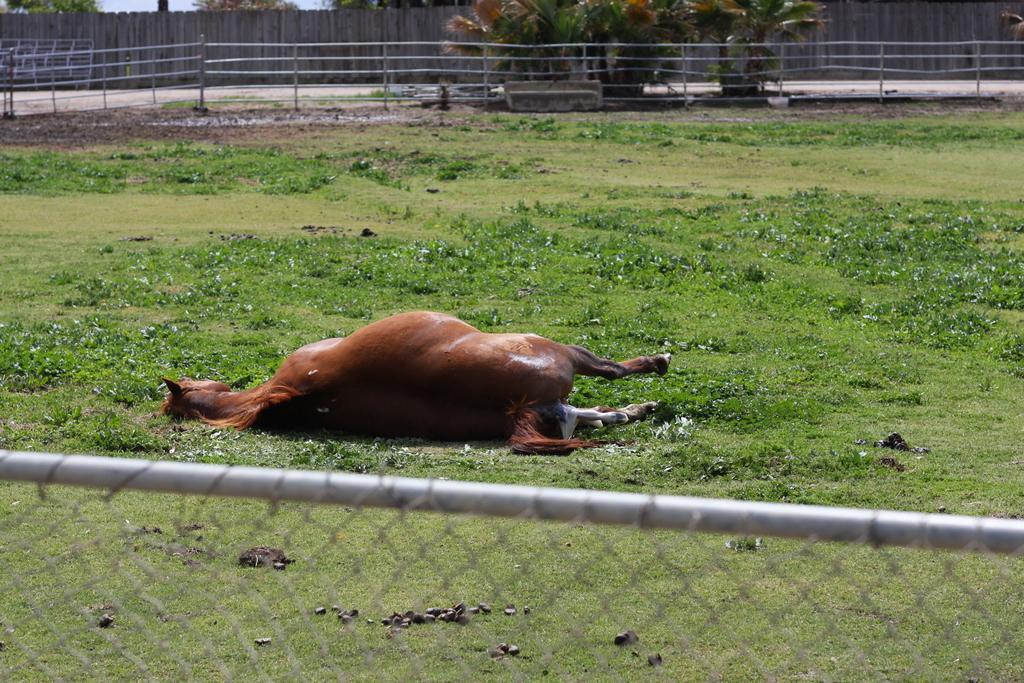How would you summarize this image in a sentence or two? In this image we can see a horse lying on the ground. We can also see some plants, grass, the metal fence, stones, a wooden fence, some plants in the pots, a pole and the sky. 